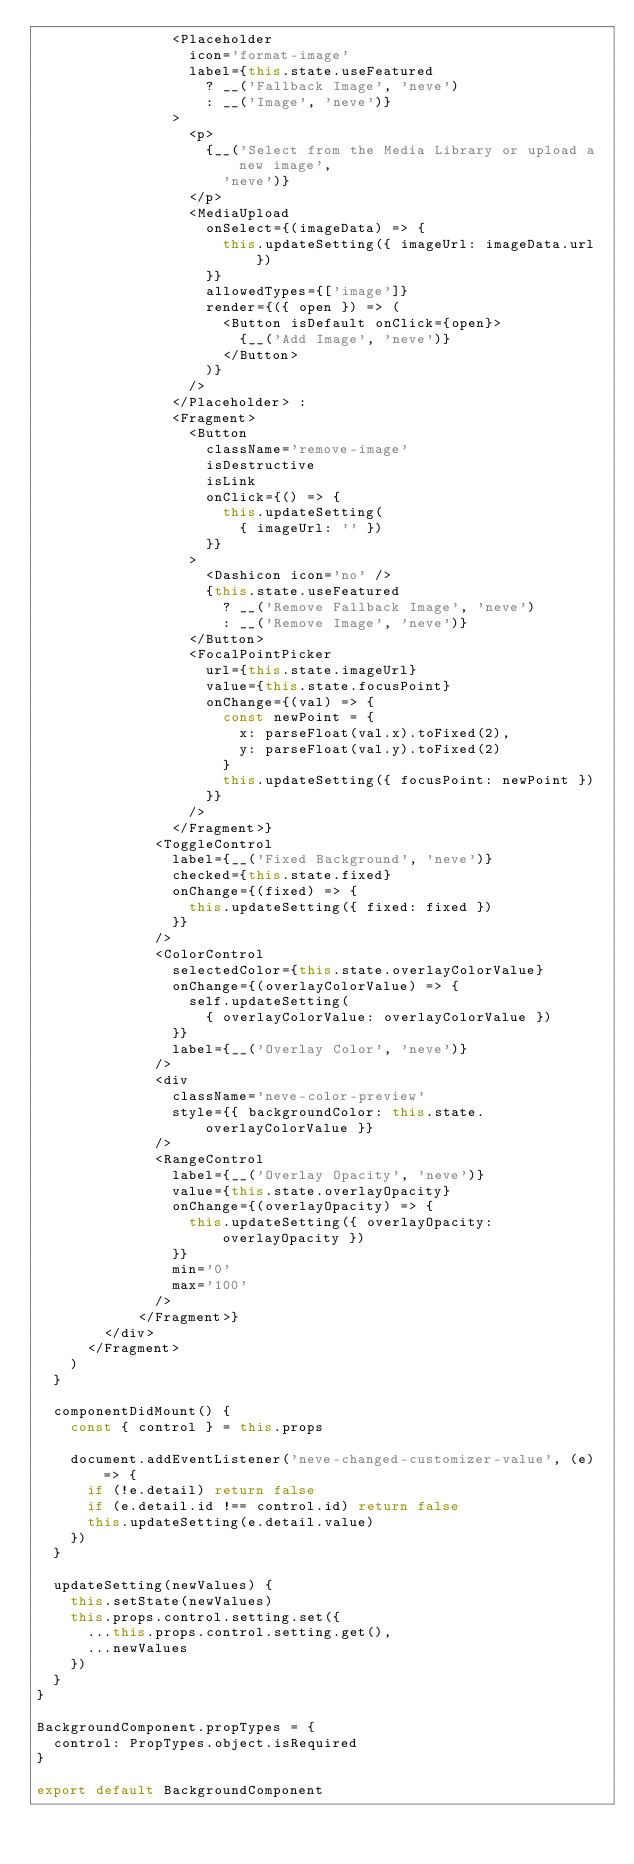<code> <loc_0><loc_0><loc_500><loc_500><_JavaScript_>                <Placeholder
                  icon='format-image'
                  label={this.state.useFeatured
                    ? __('Fallback Image', 'neve')
                    : __('Image', 'neve')}
                >
                  <p>
                    {__('Select from the Media Library or upload a new image',
                      'neve')}
                  </p>
                  <MediaUpload
                    onSelect={(imageData) => {
                      this.updateSetting({ imageUrl: imageData.url })
                    }}
                    allowedTypes={['image']}
                    render={({ open }) => (
                      <Button isDefault onClick={open}>
                        {__('Add Image', 'neve')}
                      </Button>
                    )}
                  />
                </Placeholder> :
                <Fragment>
                  <Button
                    className='remove-image'
                    isDestructive
                    isLink
                    onClick={() => {
                      this.updateSetting(
                        { imageUrl: '' })
                    }}
                  >
                    <Dashicon icon='no' />
                    {this.state.useFeatured
                      ? __('Remove Fallback Image', 'neve')
                      : __('Remove Image', 'neve')}
                  </Button>
                  <FocalPointPicker
                    url={this.state.imageUrl}
                    value={this.state.focusPoint}
                    onChange={(val) => {
                      const newPoint = {
                        x: parseFloat(val.x).toFixed(2),
                        y: parseFloat(val.y).toFixed(2)
                      }
                      this.updateSetting({ focusPoint: newPoint })
                    }}
                  />
                </Fragment>}
              <ToggleControl
                label={__('Fixed Background', 'neve')}
                checked={this.state.fixed}
                onChange={(fixed) => {
                  this.updateSetting({ fixed: fixed })
                }}
              />
              <ColorControl
                selectedColor={this.state.overlayColorValue}
                onChange={(overlayColorValue) => {
                  self.updateSetting(
                    { overlayColorValue: overlayColorValue })
                }}
                label={__('Overlay Color', 'neve')}
              />
              <div
                className='neve-color-preview'
                style={{ backgroundColor: this.state.overlayColorValue }}
              />
              <RangeControl
                label={__('Overlay Opacity', 'neve')}
                value={this.state.overlayOpacity}
                onChange={(overlayOpacity) => {
                  this.updateSetting({ overlayOpacity: overlayOpacity })
                }}
                min='0'
                max='100'
              />
            </Fragment>}
        </div>
      </Fragment>
    )
  }

  componentDidMount() {
    const { control } = this.props

    document.addEventListener('neve-changed-customizer-value', (e) => {
      if (!e.detail) return false
      if (e.detail.id !== control.id) return false
      this.updateSetting(e.detail.value)
    })
  }

  updateSetting(newValues) {
    this.setState(newValues)
    this.props.control.setting.set({
      ...this.props.control.setting.get(),
      ...newValues
    })
  }
}

BackgroundComponent.propTypes = {
  control: PropTypes.object.isRequired
}

export default BackgroundComponent
</code> 